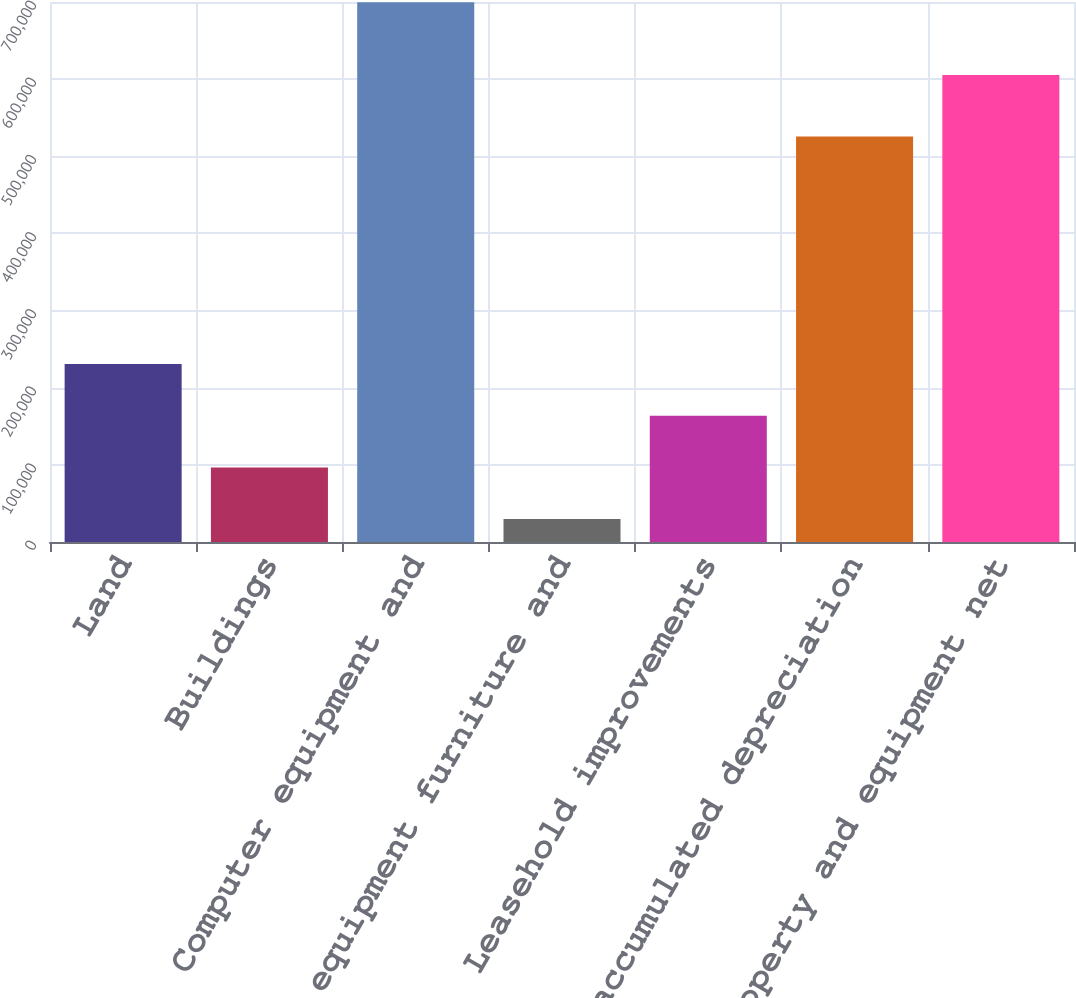Convert chart to OTSL. <chart><loc_0><loc_0><loc_500><loc_500><bar_chart><fcel>Land<fcel>Buildings<fcel>Computer equipment and<fcel>Office equipment furniture and<fcel>Leasehold improvements<fcel>Less accumulated depreciation<fcel>Property and equipment net<nl><fcel>230650<fcel>96671.4<fcel>699576<fcel>29682<fcel>163661<fcel>525511<fcel>605292<nl></chart> 